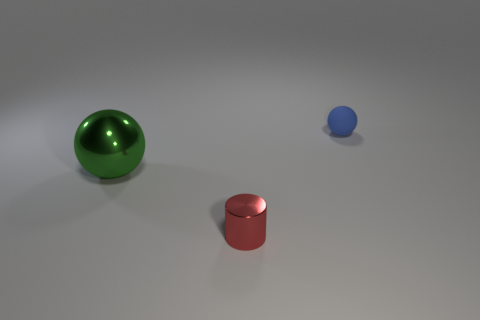Add 2 small rubber cylinders. How many objects exist? 5 Subtract all cylinders. How many objects are left? 2 Add 2 green rubber balls. How many green rubber balls exist? 2 Subtract 0 yellow cylinders. How many objects are left? 3 Subtract all big brown matte things. Subtract all green spheres. How many objects are left? 2 Add 1 metallic cylinders. How many metallic cylinders are left? 2 